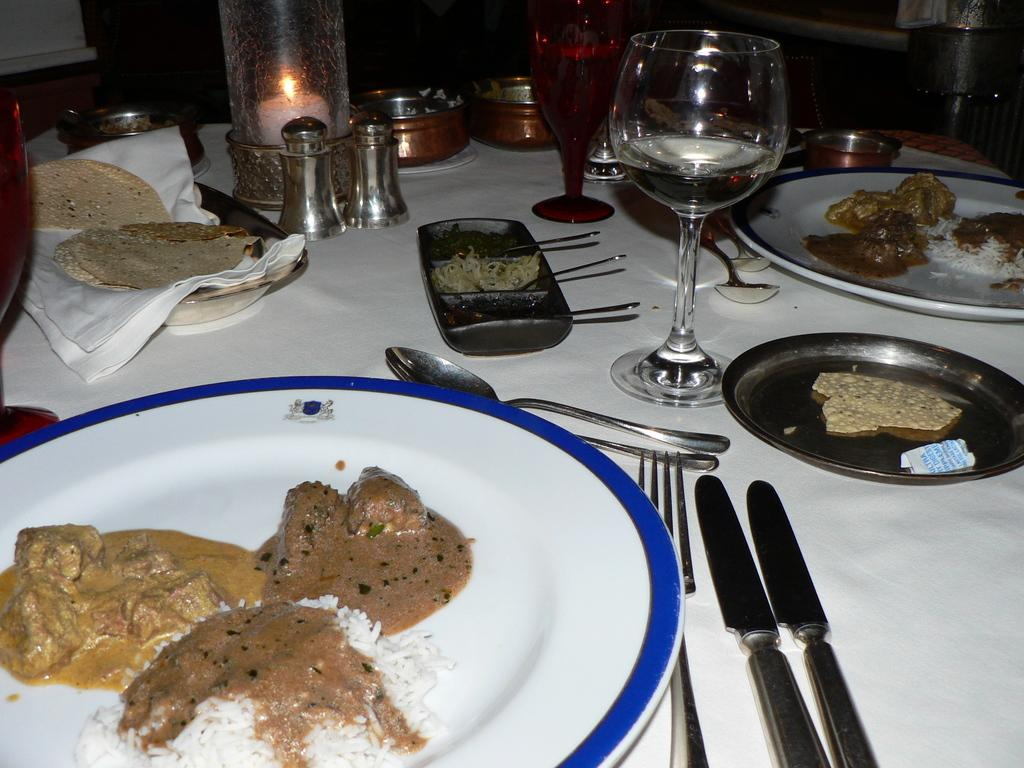What can be seen on the plates in the image? There are food items on plates in the image. What utensils are visible in the image? Spoons, forks, and knives are visible in the image. What type of containers are present in the image? Glasses are present in the image. What else can be found on the table in the image? There are other objects on the table in the image. Who is the owner of the knife in the image? There is no indication of ownership in the image, and the knife is not associated with any specific person. What is the reason for saying good-bye to the food items in the image? There is no context for saying good-bye to the food items in the image; it is simply a still image of food on plates. 